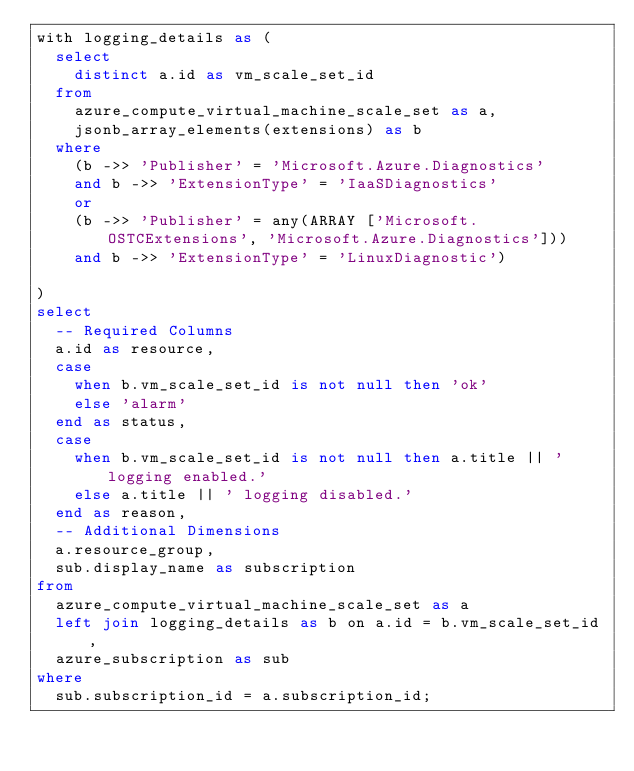Convert code to text. <code><loc_0><loc_0><loc_500><loc_500><_SQL_>with logging_details as (
  select
    distinct a.id as vm_scale_set_id
  from
    azure_compute_virtual_machine_scale_set as a,
    jsonb_array_elements(extensions) as b
  where
    (b ->> 'Publisher' = 'Microsoft.Azure.Diagnostics'
    and b ->> 'ExtensionType' = 'IaaSDiagnostics'
    or
    (b ->> 'Publisher' = any(ARRAY ['Microsoft.OSTCExtensions', 'Microsoft.Azure.Diagnostics']))
    and b ->> 'ExtensionType' = 'LinuxDiagnostic')

)
select
  -- Required Columns
  a.id as resource,
  case
    when b.vm_scale_set_id is not null then 'ok'
    else 'alarm'
  end as status,
  case
    when b.vm_scale_set_id is not null then a.title || ' logging enabled.'
    else a.title || ' logging disabled.'
  end as reason,
  -- Additional Dimensions
  a.resource_group,
  sub.display_name as subscription
from
  azure_compute_virtual_machine_scale_set as a
  left join logging_details as b on a.id = b.vm_scale_set_id,
  azure_subscription as sub
where
  sub.subscription_id = a.subscription_id;</code> 